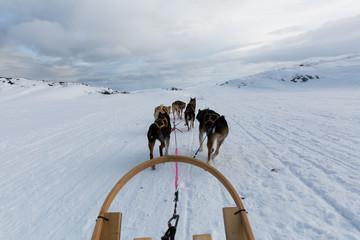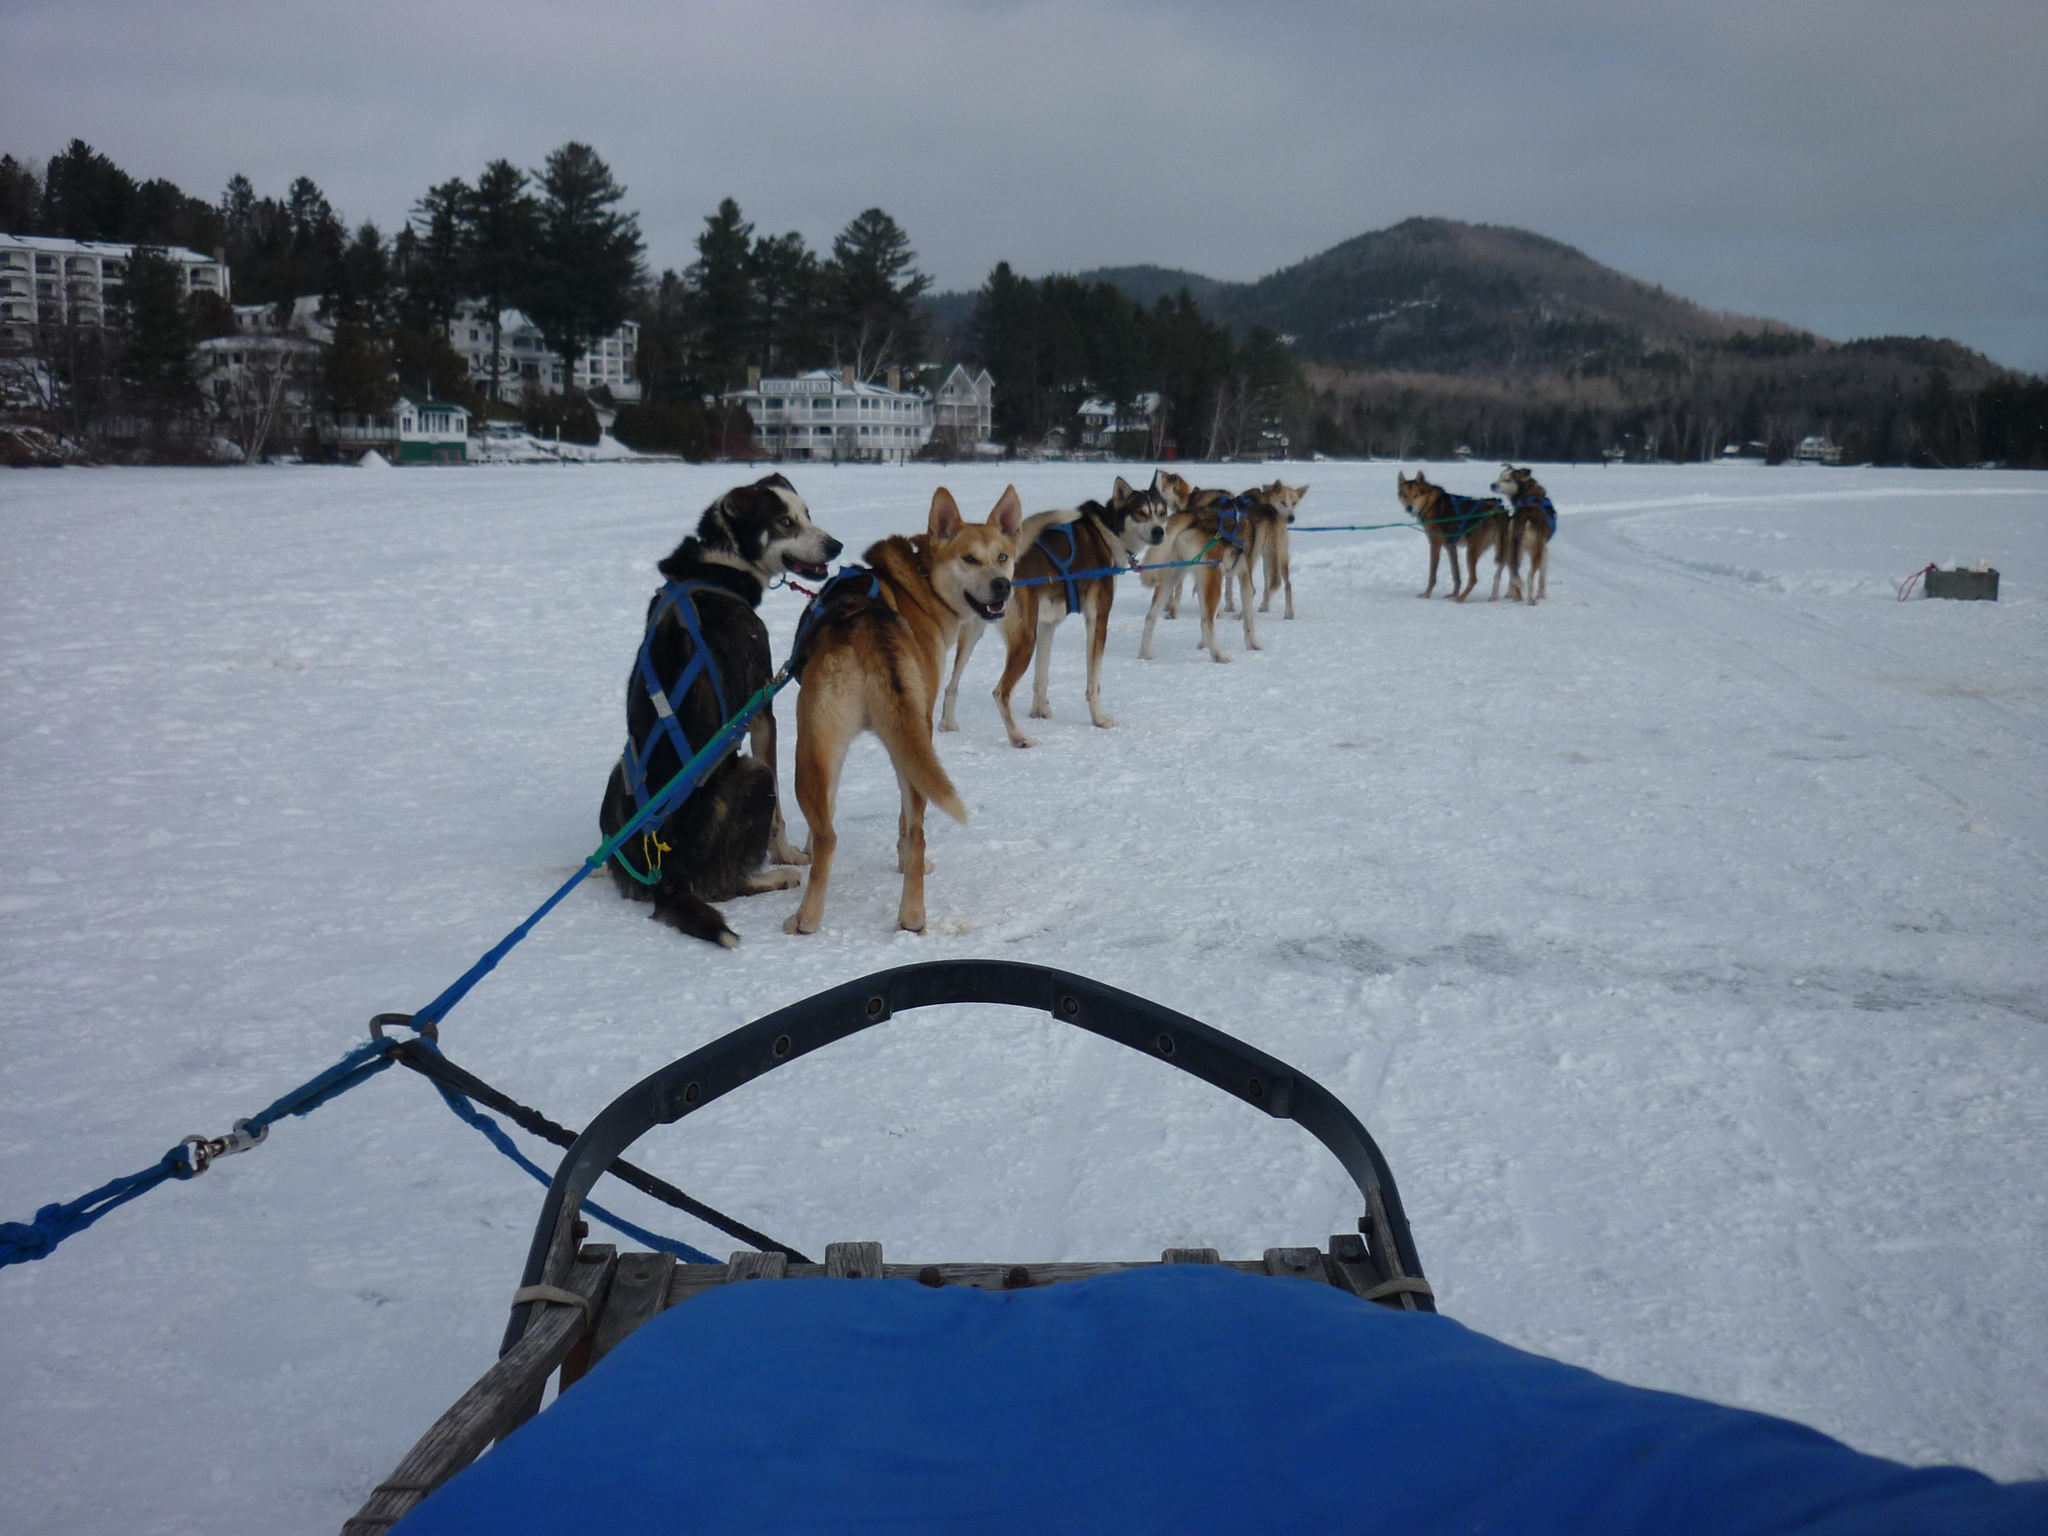The first image is the image on the left, the second image is the image on the right. For the images shown, is this caption "An image shows a semi-circle wooden front of a sled at the bottom." true? Answer yes or no. Yes. The first image is the image on the left, the second image is the image on the right. Considering the images on both sides, is "There are trees lining the trail in the image on the right" valid? Answer yes or no. No. 